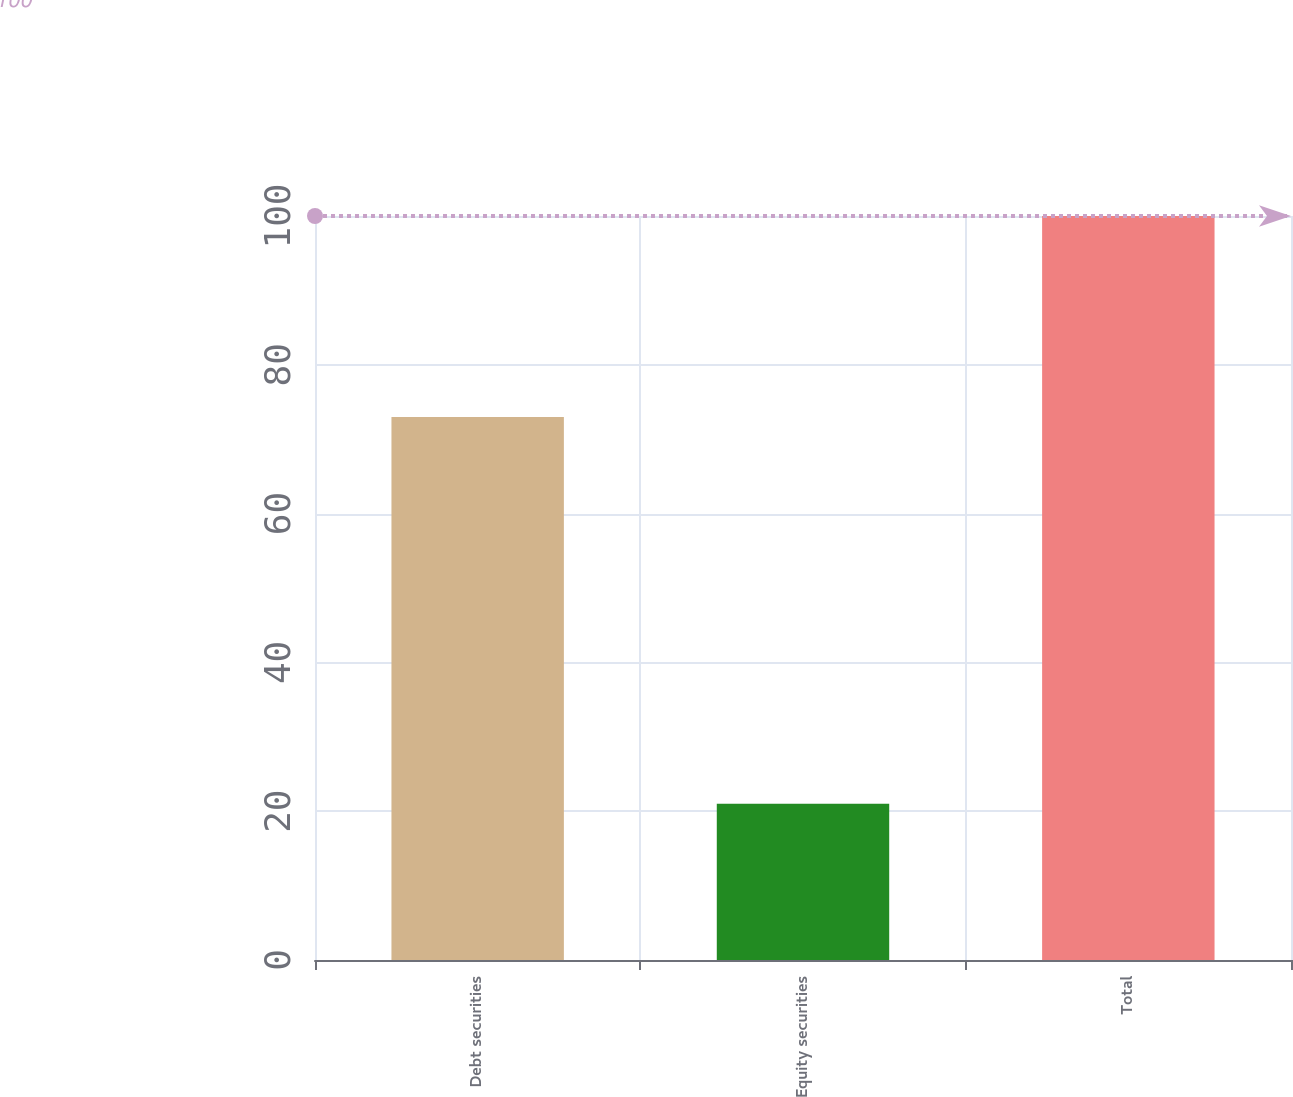Convert chart. <chart><loc_0><loc_0><loc_500><loc_500><bar_chart><fcel>Debt securities<fcel>Equity securities<fcel>Total<nl><fcel>73<fcel>21<fcel>100<nl></chart> 